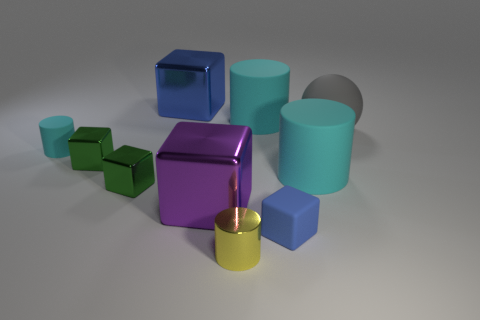There is a shiny thing that is the same color as the tiny matte cube; what shape is it?
Ensure brevity in your answer.  Cube. There is a object that is the same color as the small matte cube; what is its material?
Provide a succinct answer. Metal. There is a tiny rubber object to the right of the small yellow thing; what color is it?
Your answer should be very brief. Blue. What number of other objects are the same material as the purple thing?
Your response must be concise. 4. Is the number of yellow metal cylinders that are in front of the tiny metallic cylinder greater than the number of large spheres behind the blue metal object?
Provide a succinct answer. No. There is a purple metal block; how many tiny cyan matte cylinders are right of it?
Provide a short and direct response. 0. Is the small blue cube made of the same material as the blue object left of the small blue cube?
Offer a terse response. No. Are there any other things that have the same shape as the small blue matte thing?
Offer a very short reply. Yes. Is the material of the yellow cylinder the same as the small cyan object?
Provide a short and direct response. No. Are there any big gray balls that are behind the cyan rubber thing left of the small yellow cylinder?
Your answer should be compact. Yes. 